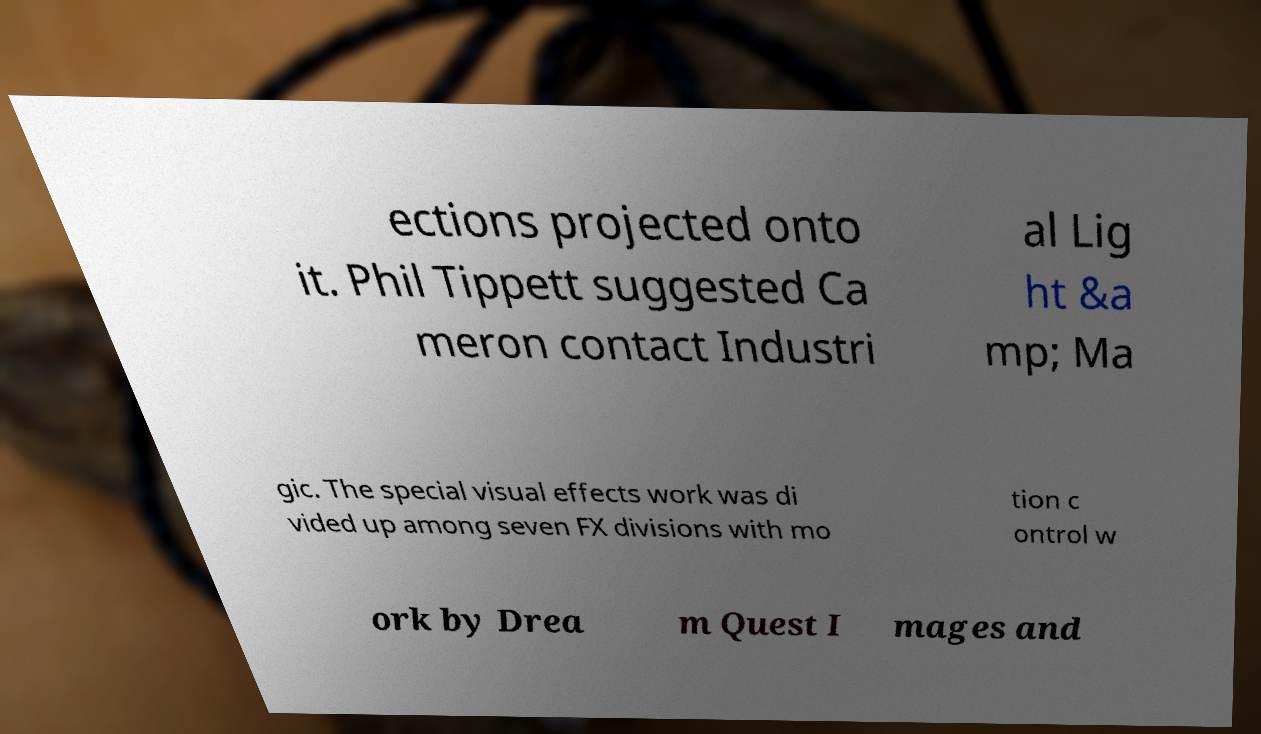What messages or text are displayed in this image? I need them in a readable, typed format. ections projected onto it. Phil Tippett suggested Ca meron contact Industri al Lig ht &a mp; Ma gic. The special visual effects work was di vided up among seven FX divisions with mo tion c ontrol w ork by Drea m Quest I mages and 